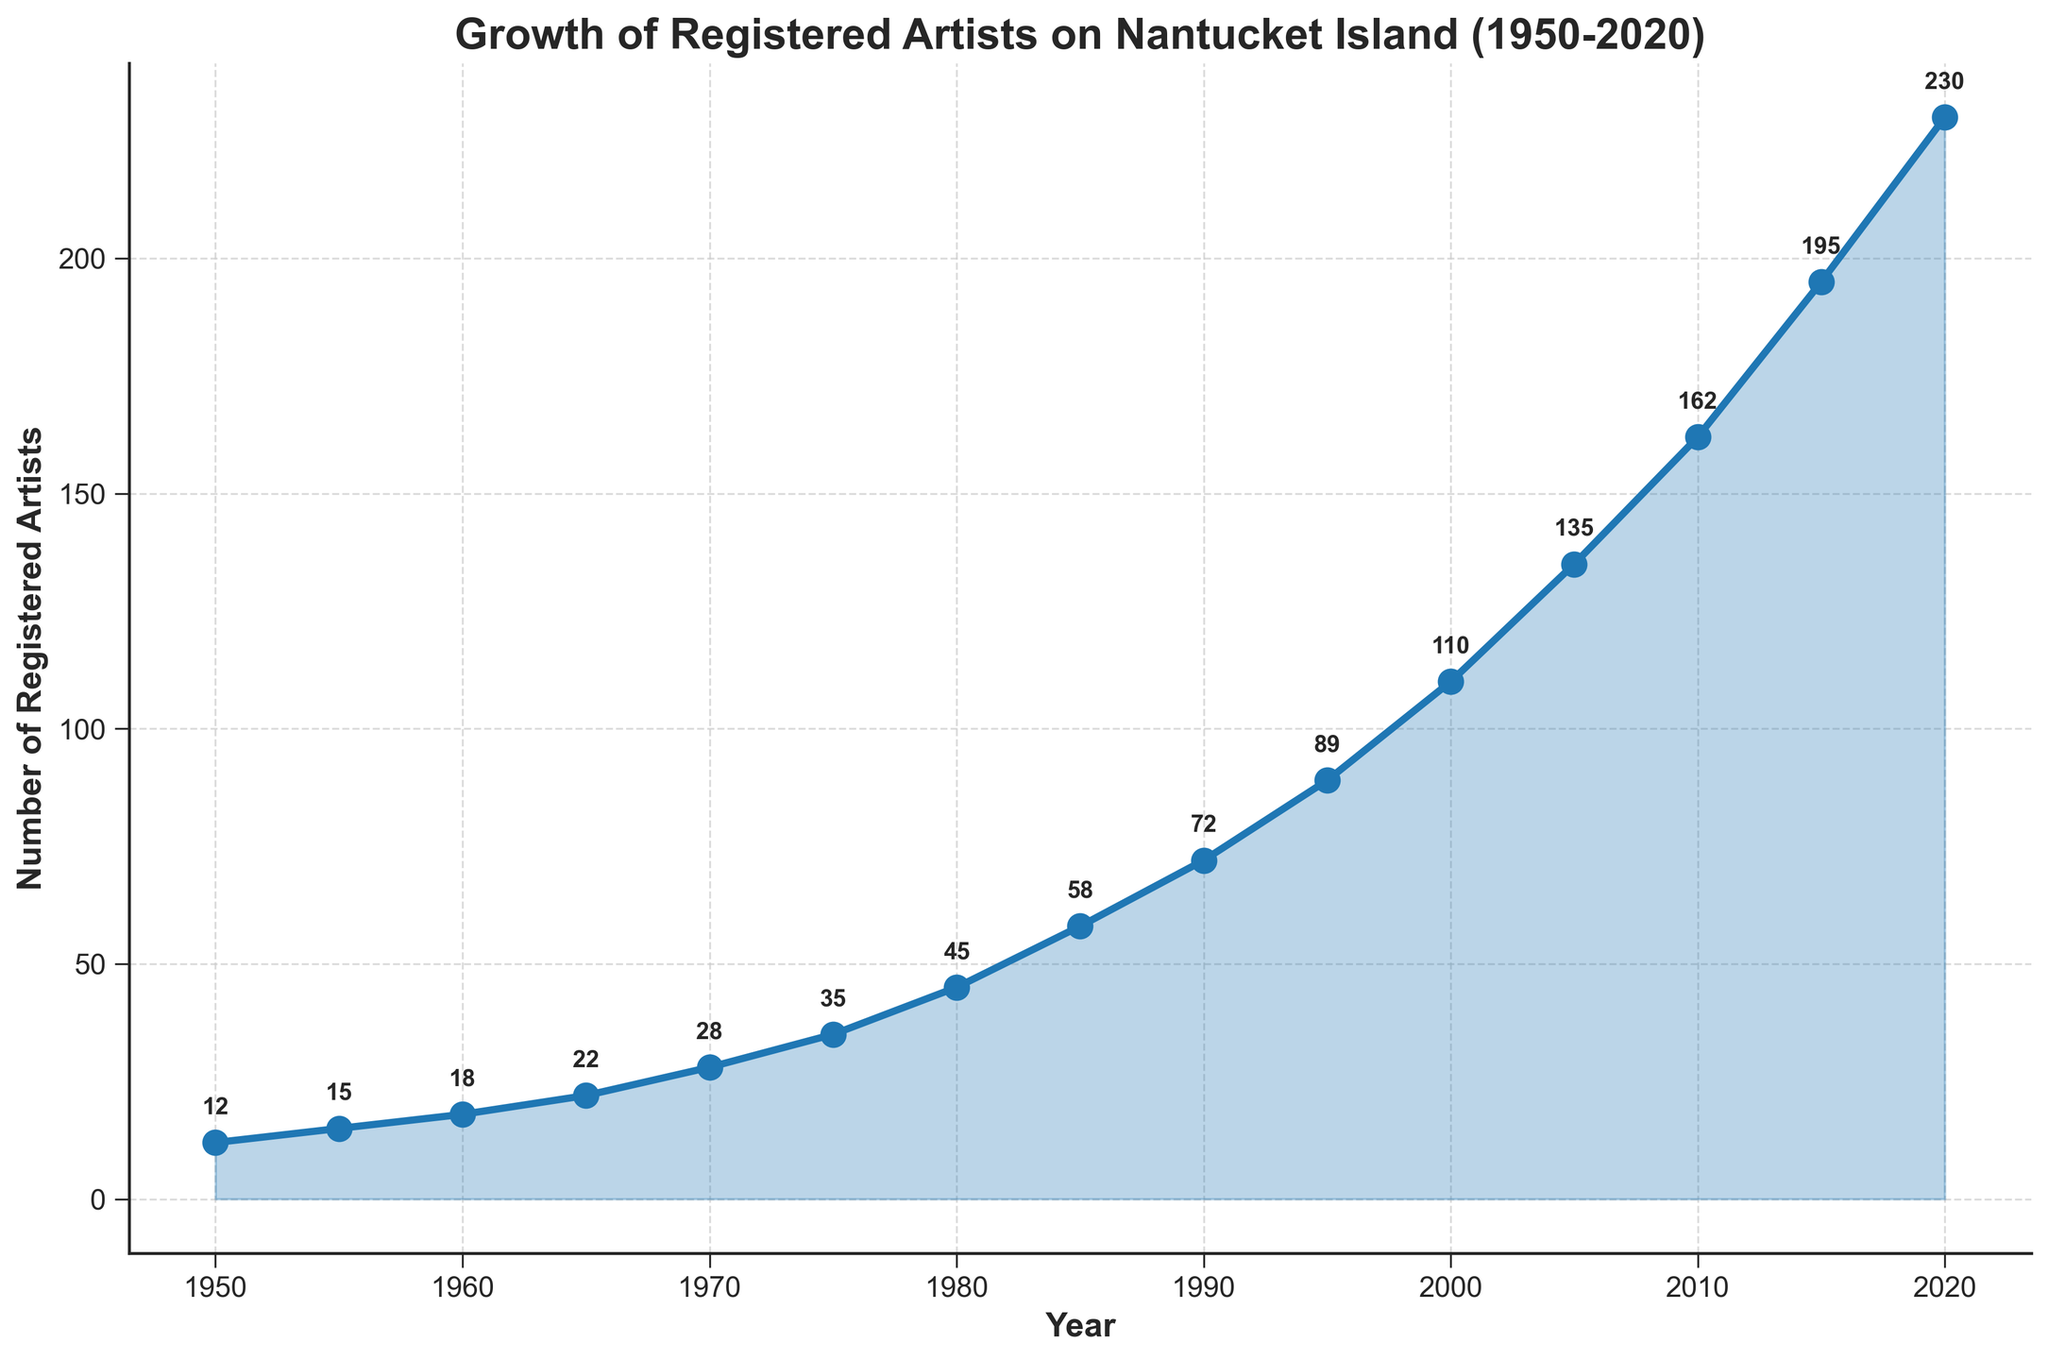How many registered artists were there in 1960? Look at the y-axis and locate the data point corresponding to the year 1960. The number of registered artists for that year is marked with an annotation.
Answer: 18 In which decade did the number of registered artists surpass 100? Identify the time period where the y-axis value exceeds 100 for the first time. This happens between 1990 and 2000.
Answer: 1990s How did the number of artists change from 1950 to 2020? Compare the data points for 1950 and 2020. In 1950, there were 12 artists, while in 2020, there were 230 artists. Subtract the former from the latter to find the change.
Answer: Increased by 218 During which period did the number of registered artists increase the most rapidly? Observe the slope of the line between data points across different time periods. The steepest slope indicates the most rapid increase, which appears most noticeable from 2000 to 2020.
Answer: 2000-2020 What is the average number of registered artists per decade from 1950 to 2020? Sum the number of artists recorded for each decade (12, 15, 18, 22, 28, 35, 45, 58, 72, 89, 110, 135, 162, 195, 230) and divide by the number of decades (7).
Answer: 93 By how much did the number of registered artists increase between the years 1980 and 1990? Check the number of artists in 1980 (45) and in 1990 (72). Subtract the former from the latter: 72 - 45.
Answer: 27 Which year had the largest number of registered artists? Identify the highest data point on the y-axis, which corresponds to the year 2020.
Answer: 2020 Did the number of registered artists grow by more than 20 in any decade? Calculate the difference in the number of artists across each consecutive decade and identify if any difference exceeds 20. The period between 2000 (110) and 2010 (162), and between 2010 (162) and 2020 (230) both exceed 20.
Answer: Yes Compare the growth rate of registered artists between 1950-1980 and 1990-2020. Which period had a higher growth rate? Calculate the total increase and the time span for each period. For 1950-1980: (45 - 12)/30 = 33 in 30 years. For 1990-2020: (230 - 72)/30 = 158 in 30 years. Compare the growth rates of the two periods.
Answer: 1990-2020 